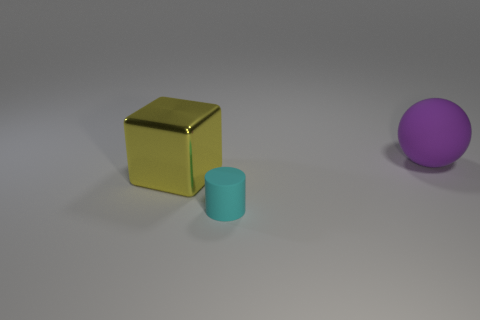How do the shapes in the image relate to each other? The shapes in the image—a sphere, a cube, and a cylinder—present a study in geometry. They are fundamental three-dimensional forms often used in art and design to explore spatial relationships and compositional balance. Here, they are arranged in a manner that creates a visual flow from left to right, with their varying forms and colors drawing the eye across the scene. 